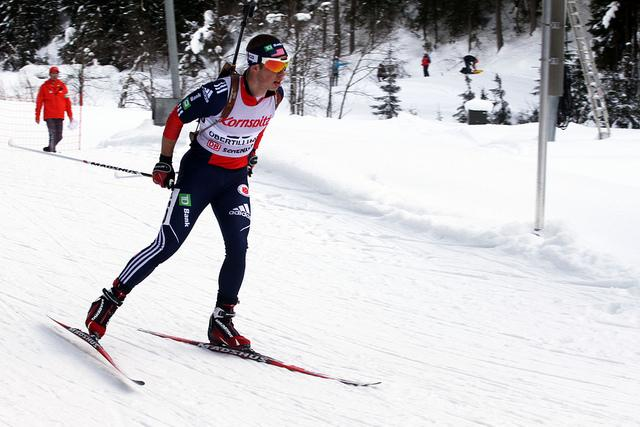What is required for this activity? Please explain your reasoning. snow. The ski is designed to slide on a smooth frozen surface. 